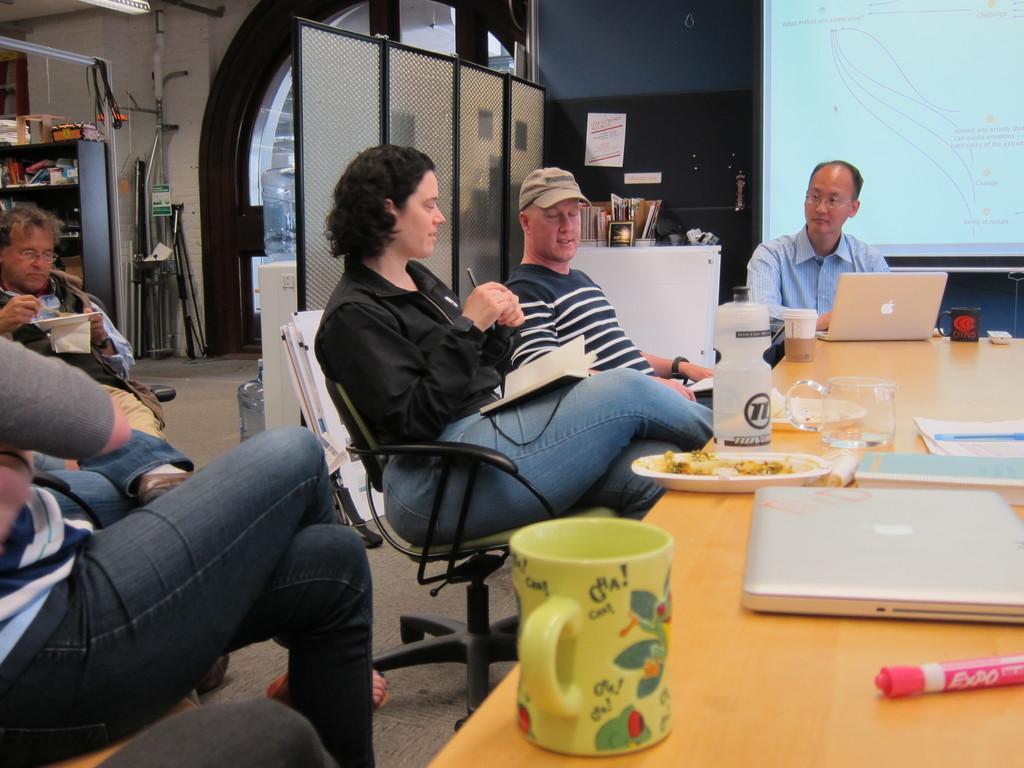How would you summarize this image in a sentence or two? This picture describes about group of people they are all seated on the chair, in front of them we can find bottle, couple of cups, glasses, plates, laptops, books and a pen on the table, behind them we can see a water filter, a projector screen, a wall and couple of books on the table. 